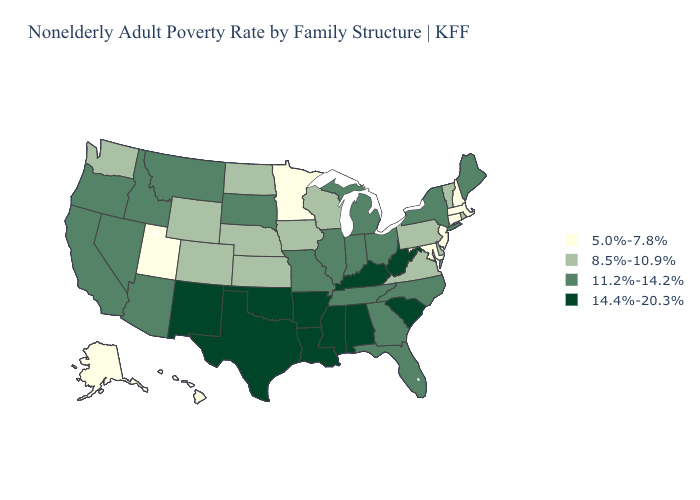Name the states that have a value in the range 14.4%-20.3%?
Concise answer only. Alabama, Arkansas, Kentucky, Louisiana, Mississippi, New Mexico, Oklahoma, South Carolina, Texas, West Virginia. Name the states that have a value in the range 5.0%-7.8%?
Write a very short answer. Alaska, Connecticut, Hawaii, Maryland, Massachusetts, Minnesota, New Hampshire, New Jersey, Utah. Does Nebraska have a higher value than South Dakota?
Concise answer only. No. Which states hav the highest value in the MidWest?
Concise answer only. Illinois, Indiana, Michigan, Missouri, Ohio, South Dakota. Name the states that have a value in the range 8.5%-10.9%?
Give a very brief answer. Colorado, Delaware, Iowa, Kansas, Nebraska, North Dakota, Pennsylvania, Rhode Island, Vermont, Virginia, Washington, Wisconsin, Wyoming. Is the legend a continuous bar?
Write a very short answer. No. Does Washington have the highest value in the West?
Give a very brief answer. No. What is the value of Ohio?
Be succinct. 11.2%-14.2%. Does the first symbol in the legend represent the smallest category?
Write a very short answer. Yes. What is the value of Mississippi?
Concise answer only. 14.4%-20.3%. Name the states that have a value in the range 8.5%-10.9%?
Short answer required. Colorado, Delaware, Iowa, Kansas, Nebraska, North Dakota, Pennsylvania, Rhode Island, Vermont, Virginia, Washington, Wisconsin, Wyoming. What is the value of West Virginia?
Short answer required. 14.4%-20.3%. Among the states that border Massachusetts , which have the lowest value?
Be succinct. Connecticut, New Hampshire. Among the states that border Iowa , does Missouri have the highest value?
Keep it brief. Yes. Name the states that have a value in the range 8.5%-10.9%?
Write a very short answer. Colorado, Delaware, Iowa, Kansas, Nebraska, North Dakota, Pennsylvania, Rhode Island, Vermont, Virginia, Washington, Wisconsin, Wyoming. 